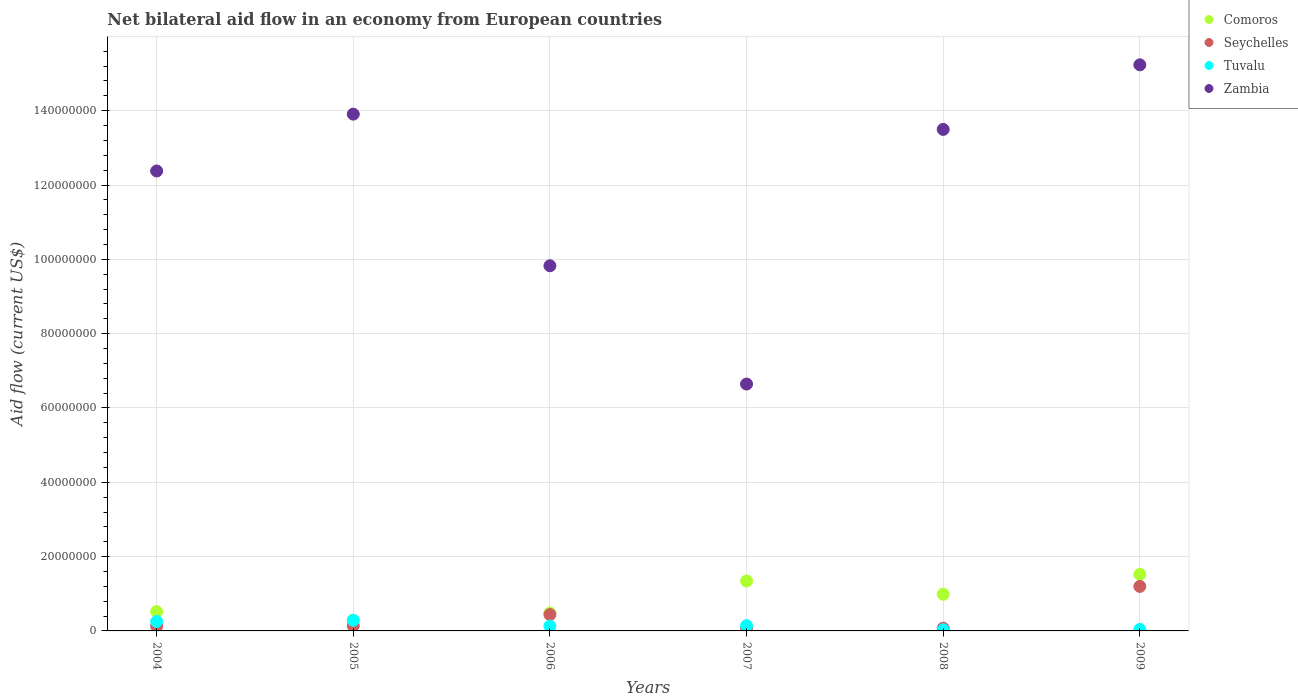What is the net bilateral aid flow in Seychelles in 2008?
Provide a succinct answer. 7.40e+05. Across all years, what is the maximum net bilateral aid flow in Seychelles?
Ensure brevity in your answer.  1.20e+07. Across all years, what is the minimum net bilateral aid flow in Comoros?
Your answer should be compact. 2.88e+06. In which year was the net bilateral aid flow in Comoros minimum?
Your answer should be compact. 2005. What is the total net bilateral aid flow in Comoros in the graph?
Your response must be concise. 5.14e+07. What is the difference between the net bilateral aid flow in Zambia in 2007 and that in 2008?
Give a very brief answer. -6.85e+07. What is the difference between the net bilateral aid flow in Comoros in 2008 and the net bilateral aid flow in Zambia in 2007?
Provide a succinct answer. -5.66e+07. What is the average net bilateral aid flow in Tuvalu per year?
Provide a succinct answer. 1.47e+06. In the year 2005, what is the difference between the net bilateral aid flow in Comoros and net bilateral aid flow in Zambia?
Offer a very short reply. -1.36e+08. In how many years, is the net bilateral aid flow in Seychelles greater than 152000000 US$?
Your answer should be compact. 0. What is the ratio of the net bilateral aid flow in Tuvalu in 2004 to that in 2007?
Your answer should be compact. 1.79. What is the difference between the highest and the second highest net bilateral aid flow in Zambia?
Your answer should be very brief. 1.33e+07. What is the difference between the highest and the lowest net bilateral aid flow in Zambia?
Make the answer very short. 8.59e+07. In how many years, is the net bilateral aid flow in Tuvalu greater than the average net bilateral aid flow in Tuvalu taken over all years?
Keep it short and to the point. 2. Does the net bilateral aid flow in Seychelles monotonically increase over the years?
Your response must be concise. No. Is the net bilateral aid flow in Comoros strictly greater than the net bilateral aid flow in Tuvalu over the years?
Your answer should be compact. Yes. Is the net bilateral aid flow in Zambia strictly less than the net bilateral aid flow in Seychelles over the years?
Offer a very short reply. No. How many dotlines are there?
Your answer should be very brief. 4. What is the difference between two consecutive major ticks on the Y-axis?
Make the answer very short. 2.00e+07. Are the values on the major ticks of Y-axis written in scientific E-notation?
Give a very brief answer. No. Does the graph contain grids?
Your response must be concise. Yes. How many legend labels are there?
Offer a terse response. 4. How are the legend labels stacked?
Ensure brevity in your answer.  Vertical. What is the title of the graph?
Ensure brevity in your answer.  Net bilateral aid flow in an economy from European countries. What is the label or title of the X-axis?
Offer a terse response. Years. What is the label or title of the Y-axis?
Make the answer very short. Aid flow (current US$). What is the Aid flow (current US$) of Comoros in 2004?
Give a very brief answer. 5.19e+06. What is the Aid flow (current US$) of Seychelles in 2004?
Offer a terse response. 1.30e+06. What is the Aid flow (current US$) of Tuvalu in 2004?
Your answer should be very brief. 2.53e+06. What is the Aid flow (current US$) in Zambia in 2004?
Provide a short and direct response. 1.24e+08. What is the Aid flow (current US$) of Comoros in 2005?
Ensure brevity in your answer.  2.88e+06. What is the Aid flow (current US$) in Seychelles in 2005?
Give a very brief answer. 1.40e+06. What is the Aid flow (current US$) in Tuvalu in 2005?
Offer a very short reply. 2.86e+06. What is the Aid flow (current US$) of Zambia in 2005?
Your response must be concise. 1.39e+08. What is the Aid flow (current US$) in Comoros in 2006?
Your answer should be very brief. 4.81e+06. What is the Aid flow (current US$) in Seychelles in 2006?
Give a very brief answer. 4.40e+06. What is the Aid flow (current US$) in Tuvalu in 2006?
Offer a terse response. 1.31e+06. What is the Aid flow (current US$) of Zambia in 2006?
Make the answer very short. 9.83e+07. What is the Aid flow (current US$) of Comoros in 2007?
Your response must be concise. 1.34e+07. What is the Aid flow (current US$) of Tuvalu in 2007?
Ensure brevity in your answer.  1.41e+06. What is the Aid flow (current US$) in Zambia in 2007?
Your response must be concise. 6.64e+07. What is the Aid flow (current US$) in Comoros in 2008?
Your response must be concise. 9.87e+06. What is the Aid flow (current US$) of Seychelles in 2008?
Offer a very short reply. 7.40e+05. What is the Aid flow (current US$) of Zambia in 2008?
Your answer should be very brief. 1.35e+08. What is the Aid flow (current US$) in Comoros in 2009?
Offer a very short reply. 1.52e+07. What is the Aid flow (current US$) in Seychelles in 2009?
Make the answer very short. 1.20e+07. What is the Aid flow (current US$) in Tuvalu in 2009?
Provide a succinct answer. 4.10e+05. What is the Aid flow (current US$) in Zambia in 2009?
Offer a very short reply. 1.52e+08. Across all years, what is the maximum Aid flow (current US$) in Comoros?
Offer a terse response. 1.52e+07. Across all years, what is the maximum Aid flow (current US$) of Seychelles?
Give a very brief answer. 1.20e+07. Across all years, what is the maximum Aid flow (current US$) in Tuvalu?
Ensure brevity in your answer.  2.86e+06. Across all years, what is the maximum Aid flow (current US$) in Zambia?
Your answer should be very brief. 1.52e+08. Across all years, what is the minimum Aid flow (current US$) of Comoros?
Your answer should be compact. 2.88e+06. Across all years, what is the minimum Aid flow (current US$) of Seychelles?
Provide a short and direct response. 7.40e+05. Across all years, what is the minimum Aid flow (current US$) in Tuvalu?
Give a very brief answer. 3.20e+05. Across all years, what is the minimum Aid flow (current US$) in Zambia?
Offer a terse response. 6.64e+07. What is the total Aid flow (current US$) in Comoros in the graph?
Your response must be concise. 5.14e+07. What is the total Aid flow (current US$) of Seychelles in the graph?
Offer a terse response. 2.06e+07. What is the total Aid flow (current US$) in Tuvalu in the graph?
Offer a terse response. 8.84e+06. What is the total Aid flow (current US$) of Zambia in the graph?
Offer a very short reply. 7.15e+08. What is the difference between the Aid flow (current US$) of Comoros in 2004 and that in 2005?
Give a very brief answer. 2.31e+06. What is the difference between the Aid flow (current US$) in Tuvalu in 2004 and that in 2005?
Make the answer very short. -3.30e+05. What is the difference between the Aid flow (current US$) in Zambia in 2004 and that in 2005?
Provide a short and direct response. -1.53e+07. What is the difference between the Aid flow (current US$) of Seychelles in 2004 and that in 2006?
Offer a very short reply. -3.10e+06. What is the difference between the Aid flow (current US$) of Tuvalu in 2004 and that in 2006?
Ensure brevity in your answer.  1.22e+06. What is the difference between the Aid flow (current US$) in Zambia in 2004 and that in 2006?
Your answer should be compact. 2.55e+07. What is the difference between the Aid flow (current US$) of Comoros in 2004 and that in 2007?
Ensure brevity in your answer.  -8.25e+06. What is the difference between the Aid flow (current US$) of Tuvalu in 2004 and that in 2007?
Give a very brief answer. 1.12e+06. What is the difference between the Aid flow (current US$) in Zambia in 2004 and that in 2007?
Provide a succinct answer. 5.73e+07. What is the difference between the Aid flow (current US$) in Comoros in 2004 and that in 2008?
Offer a very short reply. -4.68e+06. What is the difference between the Aid flow (current US$) in Seychelles in 2004 and that in 2008?
Your answer should be compact. 5.60e+05. What is the difference between the Aid flow (current US$) in Tuvalu in 2004 and that in 2008?
Your answer should be very brief. 2.21e+06. What is the difference between the Aid flow (current US$) of Zambia in 2004 and that in 2008?
Provide a succinct answer. -1.12e+07. What is the difference between the Aid flow (current US$) of Comoros in 2004 and that in 2009?
Ensure brevity in your answer.  -1.00e+07. What is the difference between the Aid flow (current US$) of Seychelles in 2004 and that in 2009?
Ensure brevity in your answer.  -1.07e+07. What is the difference between the Aid flow (current US$) of Tuvalu in 2004 and that in 2009?
Provide a short and direct response. 2.12e+06. What is the difference between the Aid flow (current US$) in Zambia in 2004 and that in 2009?
Make the answer very short. -2.86e+07. What is the difference between the Aid flow (current US$) in Comoros in 2005 and that in 2006?
Your answer should be compact. -1.93e+06. What is the difference between the Aid flow (current US$) of Tuvalu in 2005 and that in 2006?
Offer a terse response. 1.55e+06. What is the difference between the Aid flow (current US$) in Zambia in 2005 and that in 2006?
Keep it short and to the point. 4.08e+07. What is the difference between the Aid flow (current US$) in Comoros in 2005 and that in 2007?
Provide a short and direct response. -1.06e+07. What is the difference between the Aid flow (current US$) of Tuvalu in 2005 and that in 2007?
Your answer should be very brief. 1.45e+06. What is the difference between the Aid flow (current US$) in Zambia in 2005 and that in 2007?
Give a very brief answer. 7.26e+07. What is the difference between the Aid flow (current US$) in Comoros in 2005 and that in 2008?
Provide a short and direct response. -6.99e+06. What is the difference between the Aid flow (current US$) of Tuvalu in 2005 and that in 2008?
Your answer should be very brief. 2.54e+06. What is the difference between the Aid flow (current US$) in Zambia in 2005 and that in 2008?
Offer a terse response. 4.11e+06. What is the difference between the Aid flow (current US$) in Comoros in 2005 and that in 2009?
Give a very brief answer. -1.24e+07. What is the difference between the Aid flow (current US$) of Seychelles in 2005 and that in 2009?
Offer a terse response. -1.06e+07. What is the difference between the Aid flow (current US$) in Tuvalu in 2005 and that in 2009?
Give a very brief answer. 2.45e+06. What is the difference between the Aid flow (current US$) of Zambia in 2005 and that in 2009?
Your response must be concise. -1.33e+07. What is the difference between the Aid flow (current US$) in Comoros in 2006 and that in 2007?
Give a very brief answer. -8.63e+06. What is the difference between the Aid flow (current US$) in Seychelles in 2006 and that in 2007?
Provide a short and direct response. 3.60e+06. What is the difference between the Aid flow (current US$) of Zambia in 2006 and that in 2007?
Keep it short and to the point. 3.18e+07. What is the difference between the Aid flow (current US$) of Comoros in 2006 and that in 2008?
Ensure brevity in your answer.  -5.06e+06. What is the difference between the Aid flow (current US$) in Seychelles in 2006 and that in 2008?
Provide a short and direct response. 3.66e+06. What is the difference between the Aid flow (current US$) in Tuvalu in 2006 and that in 2008?
Keep it short and to the point. 9.90e+05. What is the difference between the Aid flow (current US$) in Zambia in 2006 and that in 2008?
Provide a succinct answer. -3.67e+07. What is the difference between the Aid flow (current US$) in Comoros in 2006 and that in 2009?
Give a very brief answer. -1.04e+07. What is the difference between the Aid flow (current US$) of Seychelles in 2006 and that in 2009?
Keep it short and to the point. -7.58e+06. What is the difference between the Aid flow (current US$) in Tuvalu in 2006 and that in 2009?
Offer a terse response. 9.00e+05. What is the difference between the Aid flow (current US$) of Zambia in 2006 and that in 2009?
Your answer should be very brief. -5.41e+07. What is the difference between the Aid flow (current US$) in Comoros in 2007 and that in 2008?
Provide a succinct answer. 3.57e+06. What is the difference between the Aid flow (current US$) in Tuvalu in 2007 and that in 2008?
Offer a very short reply. 1.09e+06. What is the difference between the Aid flow (current US$) of Zambia in 2007 and that in 2008?
Your response must be concise. -6.85e+07. What is the difference between the Aid flow (current US$) of Comoros in 2007 and that in 2009?
Your answer should be very brief. -1.79e+06. What is the difference between the Aid flow (current US$) in Seychelles in 2007 and that in 2009?
Ensure brevity in your answer.  -1.12e+07. What is the difference between the Aid flow (current US$) of Zambia in 2007 and that in 2009?
Your response must be concise. -8.59e+07. What is the difference between the Aid flow (current US$) of Comoros in 2008 and that in 2009?
Provide a succinct answer. -5.36e+06. What is the difference between the Aid flow (current US$) in Seychelles in 2008 and that in 2009?
Keep it short and to the point. -1.12e+07. What is the difference between the Aid flow (current US$) in Zambia in 2008 and that in 2009?
Your answer should be compact. -1.74e+07. What is the difference between the Aid flow (current US$) of Comoros in 2004 and the Aid flow (current US$) of Seychelles in 2005?
Ensure brevity in your answer.  3.79e+06. What is the difference between the Aid flow (current US$) in Comoros in 2004 and the Aid flow (current US$) in Tuvalu in 2005?
Offer a terse response. 2.33e+06. What is the difference between the Aid flow (current US$) in Comoros in 2004 and the Aid flow (current US$) in Zambia in 2005?
Your answer should be very brief. -1.34e+08. What is the difference between the Aid flow (current US$) of Seychelles in 2004 and the Aid flow (current US$) of Tuvalu in 2005?
Your answer should be very brief. -1.56e+06. What is the difference between the Aid flow (current US$) in Seychelles in 2004 and the Aid flow (current US$) in Zambia in 2005?
Offer a terse response. -1.38e+08. What is the difference between the Aid flow (current US$) of Tuvalu in 2004 and the Aid flow (current US$) of Zambia in 2005?
Provide a short and direct response. -1.37e+08. What is the difference between the Aid flow (current US$) in Comoros in 2004 and the Aid flow (current US$) in Seychelles in 2006?
Your answer should be very brief. 7.90e+05. What is the difference between the Aid flow (current US$) of Comoros in 2004 and the Aid flow (current US$) of Tuvalu in 2006?
Offer a very short reply. 3.88e+06. What is the difference between the Aid flow (current US$) in Comoros in 2004 and the Aid flow (current US$) in Zambia in 2006?
Give a very brief answer. -9.31e+07. What is the difference between the Aid flow (current US$) in Seychelles in 2004 and the Aid flow (current US$) in Tuvalu in 2006?
Keep it short and to the point. -10000. What is the difference between the Aid flow (current US$) of Seychelles in 2004 and the Aid flow (current US$) of Zambia in 2006?
Your answer should be very brief. -9.70e+07. What is the difference between the Aid flow (current US$) of Tuvalu in 2004 and the Aid flow (current US$) of Zambia in 2006?
Offer a terse response. -9.57e+07. What is the difference between the Aid flow (current US$) of Comoros in 2004 and the Aid flow (current US$) of Seychelles in 2007?
Your response must be concise. 4.39e+06. What is the difference between the Aid flow (current US$) in Comoros in 2004 and the Aid flow (current US$) in Tuvalu in 2007?
Offer a terse response. 3.78e+06. What is the difference between the Aid flow (current US$) in Comoros in 2004 and the Aid flow (current US$) in Zambia in 2007?
Offer a very short reply. -6.12e+07. What is the difference between the Aid flow (current US$) in Seychelles in 2004 and the Aid flow (current US$) in Zambia in 2007?
Your response must be concise. -6.51e+07. What is the difference between the Aid flow (current US$) of Tuvalu in 2004 and the Aid flow (current US$) of Zambia in 2007?
Offer a very short reply. -6.39e+07. What is the difference between the Aid flow (current US$) of Comoros in 2004 and the Aid flow (current US$) of Seychelles in 2008?
Provide a short and direct response. 4.45e+06. What is the difference between the Aid flow (current US$) of Comoros in 2004 and the Aid flow (current US$) of Tuvalu in 2008?
Offer a terse response. 4.87e+06. What is the difference between the Aid flow (current US$) of Comoros in 2004 and the Aid flow (current US$) of Zambia in 2008?
Your answer should be very brief. -1.30e+08. What is the difference between the Aid flow (current US$) in Seychelles in 2004 and the Aid flow (current US$) in Tuvalu in 2008?
Provide a short and direct response. 9.80e+05. What is the difference between the Aid flow (current US$) of Seychelles in 2004 and the Aid flow (current US$) of Zambia in 2008?
Keep it short and to the point. -1.34e+08. What is the difference between the Aid flow (current US$) in Tuvalu in 2004 and the Aid flow (current US$) in Zambia in 2008?
Ensure brevity in your answer.  -1.32e+08. What is the difference between the Aid flow (current US$) of Comoros in 2004 and the Aid flow (current US$) of Seychelles in 2009?
Your answer should be compact. -6.79e+06. What is the difference between the Aid flow (current US$) in Comoros in 2004 and the Aid flow (current US$) in Tuvalu in 2009?
Offer a terse response. 4.78e+06. What is the difference between the Aid flow (current US$) of Comoros in 2004 and the Aid flow (current US$) of Zambia in 2009?
Give a very brief answer. -1.47e+08. What is the difference between the Aid flow (current US$) of Seychelles in 2004 and the Aid flow (current US$) of Tuvalu in 2009?
Your answer should be compact. 8.90e+05. What is the difference between the Aid flow (current US$) in Seychelles in 2004 and the Aid flow (current US$) in Zambia in 2009?
Offer a terse response. -1.51e+08. What is the difference between the Aid flow (current US$) in Tuvalu in 2004 and the Aid flow (current US$) in Zambia in 2009?
Make the answer very short. -1.50e+08. What is the difference between the Aid flow (current US$) in Comoros in 2005 and the Aid flow (current US$) in Seychelles in 2006?
Provide a succinct answer. -1.52e+06. What is the difference between the Aid flow (current US$) in Comoros in 2005 and the Aid flow (current US$) in Tuvalu in 2006?
Your response must be concise. 1.57e+06. What is the difference between the Aid flow (current US$) in Comoros in 2005 and the Aid flow (current US$) in Zambia in 2006?
Offer a terse response. -9.54e+07. What is the difference between the Aid flow (current US$) of Seychelles in 2005 and the Aid flow (current US$) of Zambia in 2006?
Your response must be concise. -9.69e+07. What is the difference between the Aid flow (current US$) in Tuvalu in 2005 and the Aid flow (current US$) in Zambia in 2006?
Ensure brevity in your answer.  -9.54e+07. What is the difference between the Aid flow (current US$) in Comoros in 2005 and the Aid flow (current US$) in Seychelles in 2007?
Provide a succinct answer. 2.08e+06. What is the difference between the Aid flow (current US$) in Comoros in 2005 and the Aid flow (current US$) in Tuvalu in 2007?
Provide a short and direct response. 1.47e+06. What is the difference between the Aid flow (current US$) in Comoros in 2005 and the Aid flow (current US$) in Zambia in 2007?
Offer a very short reply. -6.36e+07. What is the difference between the Aid flow (current US$) of Seychelles in 2005 and the Aid flow (current US$) of Zambia in 2007?
Ensure brevity in your answer.  -6.50e+07. What is the difference between the Aid flow (current US$) in Tuvalu in 2005 and the Aid flow (current US$) in Zambia in 2007?
Keep it short and to the point. -6.36e+07. What is the difference between the Aid flow (current US$) in Comoros in 2005 and the Aid flow (current US$) in Seychelles in 2008?
Your answer should be very brief. 2.14e+06. What is the difference between the Aid flow (current US$) of Comoros in 2005 and the Aid flow (current US$) of Tuvalu in 2008?
Give a very brief answer. 2.56e+06. What is the difference between the Aid flow (current US$) in Comoros in 2005 and the Aid flow (current US$) in Zambia in 2008?
Your answer should be very brief. -1.32e+08. What is the difference between the Aid flow (current US$) of Seychelles in 2005 and the Aid flow (current US$) of Tuvalu in 2008?
Your response must be concise. 1.08e+06. What is the difference between the Aid flow (current US$) of Seychelles in 2005 and the Aid flow (current US$) of Zambia in 2008?
Give a very brief answer. -1.34e+08. What is the difference between the Aid flow (current US$) in Tuvalu in 2005 and the Aid flow (current US$) in Zambia in 2008?
Give a very brief answer. -1.32e+08. What is the difference between the Aid flow (current US$) in Comoros in 2005 and the Aid flow (current US$) in Seychelles in 2009?
Your response must be concise. -9.10e+06. What is the difference between the Aid flow (current US$) of Comoros in 2005 and the Aid flow (current US$) of Tuvalu in 2009?
Your response must be concise. 2.47e+06. What is the difference between the Aid flow (current US$) of Comoros in 2005 and the Aid flow (current US$) of Zambia in 2009?
Give a very brief answer. -1.49e+08. What is the difference between the Aid flow (current US$) in Seychelles in 2005 and the Aid flow (current US$) in Tuvalu in 2009?
Offer a very short reply. 9.90e+05. What is the difference between the Aid flow (current US$) of Seychelles in 2005 and the Aid flow (current US$) of Zambia in 2009?
Your answer should be compact. -1.51e+08. What is the difference between the Aid flow (current US$) in Tuvalu in 2005 and the Aid flow (current US$) in Zambia in 2009?
Give a very brief answer. -1.49e+08. What is the difference between the Aid flow (current US$) of Comoros in 2006 and the Aid flow (current US$) of Seychelles in 2007?
Make the answer very short. 4.01e+06. What is the difference between the Aid flow (current US$) in Comoros in 2006 and the Aid flow (current US$) in Tuvalu in 2007?
Your response must be concise. 3.40e+06. What is the difference between the Aid flow (current US$) in Comoros in 2006 and the Aid flow (current US$) in Zambia in 2007?
Your response must be concise. -6.16e+07. What is the difference between the Aid flow (current US$) of Seychelles in 2006 and the Aid flow (current US$) of Tuvalu in 2007?
Your answer should be very brief. 2.99e+06. What is the difference between the Aid flow (current US$) in Seychelles in 2006 and the Aid flow (current US$) in Zambia in 2007?
Ensure brevity in your answer.  -6.20e+07. What is the difference between the Aid flow (current US$) in Tuvalu in 2006 and the Aid flow (current US$) in Zambia in 2007?
Give a very brief answer. -6.51e+07. What is the difference between the Aid flow (current US$) of Comoros in 2006 and the Aid flow (current US$) of Seychelles in 2008?
Make the answer very short. 4.07e+06. What is the difference between the Aid flow (current US$) in Comoros in 2006 and the Aid flow (current US$) in Tuvalu in 2008?
Your response must be concise. 4.49e+06. What is the difference between the Aid flow (current US$) of Comoros in 2006 and the Aid flow (current US$) of Zambia in 2008?
Offer a terse response. -1.30e+08. What is the difference between the Aid flow (current US$) of Seychelles in 2006 and the Aid flow (current US$) of Tuvalu in 2008?
Your answer should be compact. 4.08e+06. What is the difference between the Aid flow (current US$) of Seychelles in 2006 and the Aid flow (current US$) of Zambia in 2008?
Offer a very short reply. -1.31e+08. What is the difference between the Aid flow (current US$) of Tuvalu in 2006 and the Aid flow (current US$) of Zambia in 2008?
Provide a short and direct response. -1.34e+08. What is the difference between the Aid flow (current US$) of Comoros in 2006 and the Aid flow (current US$) of Seychelles in 2009?
Provide a succinct answer. -7.17e+06. What is the difference between the Aid flow (current US$) of Comoros in 2006 and the Aid flow (current US$) of Tuvalu in 2009?
Keep it short and to the point. 4.40e+06. What is the difference between the Aid flow (current US$) of Comoros in 2006 and the Aid flow (current US$) of Zambia in 2009?
Your answer should be very brief. -1.48e+08. What is the difference between the Aid flow (current US$) in Seychelles in 2006 and the Aid flow (current US$) in Tuvalu in 2009?
Provide a short and direct response. 3.99e+06. What is the difference between the Aid flow (current US$) in Seychelles in 2006 and the Aid flow (current US$) in Zambia in 2009?
Provide a succinct answer. -1.48e+08. What is the difference between the Aid flow (current US$) in Tuvalu in 2006 and the Aid flow (current US$) in Zambia in 2009?
Make the answer very short. -1.51e+08. What is the difference between the Aid flow (current US$) of Comoros in 2007 and the Aid flow (current US$) of Seychelles in 2008?
Your response must be concise. 1.27e+07. What is the difference between the Aid flow (current US$) of Comoros in 2007 and the Aid flow (current US$) of Tuvalu in 2008?
Provide a short and direct response. 1.31e+07. What is the difference between the Aid flow (current US$) in Comoros in 2007 and the Aid flow (current US$) in Zambia in 2008?
Offer a terse response. -1.22e+08. What is the difference between the Aid flow (current US$) in Seychelles in 2007 and the Aid flow (current US$) in Zambia in 2008?
Offer a terse response. -1.34e+08. What is the difference between the Aid flow (current US$) in Tuvalu in 2007 and the Aid flow (current US$) in Zambia in 2008?
Offer a very short reply. -1.34e+08. What is the difference between the Aid flow (current US$) in Comoros in 2007 and the Aid flow (current US$) in Seychelles in 2009?
Your answer should be compact. 1.46e+06. What is the difference between the Aid flow (current US$) of Comoros in 2007 and the Aid flow (current US$) of Tuvalu in 2009?
Provide a succinct answer. 1.30e+07. What is the difference between the Aid flow (current US$) of Comoros in 2007 and the Aid flow (current US$) of Zambia in 2009?
Ensure brevity in your answer.  -1.39e+08. What is the difference between the Aid flow (current US$) of Seychelles in 2007 and the Aid flow (current US$) of Tuvalu in 2009?
Provide a succinct answer. 3.90e+05. What is the difference between the Aid flow (current US$) in Seychelles in 2007 and the Aid flow (current US$) in Zambia in 2009?
Give a very brief answer. -1.52e+08. What is the difference between the Aid flow (current US$) in Tuvalu in 2007 and the Aid flow (current US$) in Zambia in 2009?
Offer a very short reply. -1.51e+08. What is the difference between the Aid flow (current US$) of Comoros in 2008 and the Aid flow (current US$) of Seychelles in 2009?
Your answer should be very brief. -2.11e+06. What is the difference between the Aid flow (current US$) of Comoros in 2008 and the Aid flow (current US$) of Tuvalu in 2009?
Your response must be concise. 9.46e+06. What is the difference between the Aid flow (current US$) in Comoros in 2008 and the Aid flow (current US$) in Zambia in 2009?
Ensure brevity in your answer.  -1.42e+08. What is the difference between the Aid flow (current US$) of Seychelles in 2008 and the Aid flow (current US$) of Tuvalu in 2009?
Ensure brevity in your answer.  3.30e+05. What is the difference between the Aid flow (current US$) in Seychelles in 2008 and the Aid flow (current US$) in Zambia in 2009?
Make the answer very short. -1.52e+08. What is the difference between the Aid flow (current US$) of Tuvalu in 2008 and the Aid flow (current US$) of Zambia in 2009?
Offer a very short reply. -1.52e+08. What is the average Aid flow (current US$) in Comoros per year?
Your answer should be very brief. 8.57e+06. What is the average Aid flow (current US$) of Seychelles per year?
Your answer should be very brief. 3.44e+06. What is the average Aid flow (current US$) of Tuvalu per year?
Your response must be concise. 1.47e+06. What is the average Aid flow (current US$) in Zambia per year?
Offer a terse response. 1.19e+08. In the year 2004, what is the difference between the Aid flow (current US$) of Comoros and Aid flow (current US$) of Seychelles?
Your response must be concise. 3.89e+06. In the year 2004, what is the difference between the Aid flow (current US$) of Comoros and Aid flow (current US$) of Tuvalu?
Offer a very short reply. 2.66e+06. In the year 2004, what is the difference between the Aid flow (current US$) in Comoros and Aid flow (current US$) in Zambia?
Your response must be concise. -1.19e+08. In the year 2004, what is the difference between the Aid flow (current US$) in Seychelles and Aid flow (current US$) in Tuvalu?
Your answer should be compact. -1.23e+06. In the year 2004, what is the difference between the Aid flow (current US$) in Seychelles and Aid flow (current US$) in Zambia?
Your answer should be very brief. -1.22e+08. In the year 2004, what is the difference between the Aid flow (current US$) of Tuvalu and Aid flow (current US$) of Zambia?
Keep it short and to the point. -1.21e+08. In the year 2005, what is the difference between the Aid flow (current US$) of Comoros and Aid flow (current US$) of Seychelles?
Provide a succinct answer. 1.48e+06. In the year 2005, what is the difference between the Aid flow (current US$) of Comoros and Aid flow (current US$) of Zambia?
Make the answer very short. -1.36e+08. In the year 2005, what is the difference between the Aid flow (current US$) in Seychelles and Aid flow (current US$) in Tuvalu?
Ensure brevity in your answer.  -1.46e+06. In the year 2005, what is the difference between the Aid flow (current US$) of Seychelles and Aid flow (current US$) of Zambia?
Give a very brief answer. -1.38e+08. In the year 2005, what is the difference between the Aid flow (current US$) of Tuvalu and Aid flow (current US$) of Zambia?
Your answer should be very brief. -1.36e+08. In the year 2006, what is the difference between the Aid flow (current US$) in Comoros and Aid flow (current US$) in Seychelles?
Give a very brief answer. 4.10e+05. In the year 2006, what is the difference between the Aid flow (current US$) in Comoros and Aid flow (current US$) in Tuvalu?
Offer a very short reply. 3.50e+06. In the year 2006, what is the difference between the Aid flow (current US$) of Comoros and Aid flow (current US$) of Zambia?
Give a very brief answer. -9.35e+07. In the year 2006, what is the difference between the Aid flow (current US$) of Seychelles and Aid flow (current US$) of Tuvalu?
Give a very brief answer. 3.09e+06. In the year 2006, what is the difference between the Aid flow (current US$) in Seychelles and Aid flow (current US$) in Zambia?
Your response must be concise. -9.39e+07. In the year 2006, what is the difference between the Aid flow (current US$) in Tuvalu and Aid flow (current US$) in Zambia?
Offer a terse response. -9.70e+07. In the year 2007, what is the difference between the Aid flow (current US$) of Comoros and Aid flow (current US$) of Seychelles?
Your response must be concise. 1.26e+07. In the year 2007, what is the difference between the Aid flow (current US$) in Comoros and Aid flow (current US$) in Tuvalu?
Provide a succinct answer. 1.20e+07. In the year 2007, what is the difference between the Aid flow (current US$) in Comoros and Aid flow (current US$) in Zambia?
Provide a succinct answer. -5.30e+07. In the year 2007, what is the difference between the Aid flow (current US$) of Seychelles and Aid flow (current US$) of Tuvalu?
Ensure brevity in your answer.  -6.10e+05. In the year 2007, what is the difference between the Aid flow (current US$) in Seychelles and Aid flow (current US$) in Zambia?
Make the answer very short. -6.56e+07. In the year 2007, what is the difference between the Aid flow (current US$) in Tuvalu and Aid flow (current US$) in Zambia?
Your response must be concise. -6.50e+07. In the year 2008, what is the difference between the Aid flow (current US$) in Comoros and Aid flow (current US$) in Seychelles?
Keep it short and to the point. 9.13e+06. In the year 2008, what is the difference between the Aid flow (current US$) in Comoros and Aid flow (current US$) in Tuvalu?
Your response must be concise. 9.55e+06. In the year 2008, what is the difference between the Aid flow (current US$) in Comoros and Aid flow (current US$) in Zambia?
Provide a short and direct response. -1.25e+08. In the year 2008, what is the difference between the Aid flow (current US$) of Seychelles and Aid flow (current US$) of Zambia?
Provide a short and direct response. -1.34e+08. In the year 2008, what is the difference between the Aid flow (current US$) of Tuvalu and Aid flow (current US$) of Zambia?
Make the answer very short. -1.35e+08. In the year 2009, what is the difference between the Aid flow (current US$) in Comoros and Aid flow (current US$) in Seychelles?
Offer a terse response. 3.25e+06. In the year 2009, what is the difference between the Aid flow (current US$) in Comoros and Aid flow (current US$) in Tuvalu?
Provide a succinct answer. 1.48e+07. In the year 2009, what is the difference between the Aid flow (current US$) in Comoros and Aid flow (current US$) in Zambia?
Keep it short and to the point. -1.37e+08. In the year 2009, what is the difference between the Aid flow (current US$) of Seychelles and Aid flow (current US$) of Tuvalu?
Offer a very short reply. 1.16e+07. In the year 2009, what is the difference between the Aid flow (current US$) of Seychelles and Aid flow (current US$) of Zambia?
Offer a terse response. -1.40e+08. In the year 2009, what is the difference between the Aid flow (current US$) of Tuvalu and Aid flow (current US$) of Zambia?
Keep it short and to the point. -1.52e+08. What is the ratio of the Aid flow (current US$) of Comoros in 2004 to that in 2005?
Keep it short and to the point. 1.8. What is the ratio of the Aid flow (current US$) in Tuvalu in 2004 to that in 2005?
Keep it short and to the point. 0.88. What is the ratio of the Aid flow (current US$) in Zambia in 2004 to that in 2005?
Provide a succinct answer. 0.89. What is the ratio of the Aid flow (current US$) of Comoros in 2004 to that in 2006?
Keep it short and to the point. 1.08. What is the ratio of the Aid flow (current US$) of Seychelles in 2004 to that in 2006?
Make the answer very short. 0.3. What is the ratio of the Aid flow (current US$) in Tuvalu in 2004 to that in 2006?
Keep it short and to the point. 1.93. What is the ratio of the Aid flow (current US$) in Zambia in 2004 to that in 2006?
Provide a short and direct response. 1.26. What is the ratio of the Aid flow (current US$) in Comoros in 2004 to that in 2007?
Ensure brevity in your answer.  0.39. What is the ratio of the Aid flow (current US$) of Seychelles in 2004 to that in 2007?
Offer a very short reply. 1.62. What is the ratio of the Aid flow (current US$) of Tuvalu in 2004 to that in 2007?
Offer a very short reply. 1.79. What is the ratio of the Aid flow (current US$) in Zambia in 2004 to that in 2007?
Ensure brevity in your answer.  1.86. What is the ratio of the Aid flow (current US$) of Comoros in 2004 to that in 2008?
Offer a very short reply. 0.53. What is the ratio of the Aid flow (current US$) in Seychelles in 2004 to that in 2008?
Offer a terse response. 1.76. What is the ratio of the Aid flow (current US$) of Tuvalu in 2004 to that in 2008?
Provide a short and direct response. 7.91. What is the ratio of the Aid flow (current US$) in Zambia in 2004 to that in 2008?
Give a very brief answer. 0.92. What is the ratio of the Aid flow (current US$) of Comoros in 2004 to that in 2009?
Keep it short and to the point. 0.34. What is the ratio of the Aid flow (current US$) in Seychelles in 2004 to that in 2009?
Your answer should be very brief. 0.11. What is the ratio of the Aid flow (current US$) in Tuvalu in 2004 to that in 2009?
Keep it short and to the point. 6.17. What is the ratio of the Aid flow (current US$) in Zambia in 2004 to that in 2009?
Your answer should be compact. 0.81. What is the ratio of the Aid flow (current US$) of Comoros in 2005 to that in 2006?
Offer a very short reply. 0.6. What is the ratio of the Aid flow (current US$) in Seychelles in 2005 to that in 2006?
Your response must be concise. 0.32. What is the ratio of the Aid flow (current US$) of Tuvalu in 2005 to that in 2006?
Provide a succinct answer. 2.18. What is the ratio of the Aid flow (current US$) in Zambia in 2005 to that in 2006?
Provide a succinct answer. 1.42. What is the ratio of the Aid flow (current US$) of Comoros in 2005 to that in 2007?
Offer a terse response. 0.21. What is the ratio of the Aid flow (current US$) of Tuvalu in 2005 to that in 2007?
Keep it short and to the point. 2.03. What is the ratio of the Aid flow (current US$) of Zambia in 2005 to that in 2007?
Offer a very short reply. 2.09. What is the ratio of the Aid flow (current US$) of Comoros in 2005 to that in 2008?
Offer a terse response. 0.29. What is the ratio of the Aid flow (current US$) in Seychelles in 2005 to that in 2008?
Offer a very short reply. 1.89. What is the ratio of the Aid flow (current US$) in Tuvalu in 2005 to that in 2008?
Your response must be concise. 8.94. What is the ratio of the Aid flow (current US$) in Zambia in 2005 to that in 2008?
Ensure brevity in your answer.  1.03. What is the ratio of the Aid flow (current US$) of Comoros in 2005 to that in 2009?
Offer a terse response. 0.19. What is the ratio of the Aid flow (current US$) of Seychelles in 2005 to that in 2009?
Provide a short and direct response. 0.12. What is the ratio of the Aid flow (current US$) of Tuvalu in 2005 to that in 2009?
Keep it short and to the point. 6.98. What is the ratio of the Aid flow (current US$) in Zambia in 2005 to that in 2009?
Your answer should be very brief. 0.91. What is the ratio of the Aid flow (current US$) in Comoros in 2006 to that in 2007?
Ensure brevity in your answer.  0.36. What is the ratio of the Aid flow (current US$) in Tuvalu in 2006 to that in 2007?
Give a very brief answer. 0.93. What is the ratio of the Aid flow (current US$) of Zambia in 2006 to that in 2007?
Give a very brief answer. 1.48. What is the ratio of the Aid flow (current US$) of Comoros in 2006 to that in 2008?
Your response must be concise. 0.49. What is the ratio of the Aid flow (current US$) of Seychelles in 2006 to that in 2008?
Offer a terse response. 5.95. What is the ratio of the Aid flow (current US$) of Tuvalu in 2006 to that in 2008?
Ensure brevity in your answer.  4.09. What is the ratio of the Aid flow (current US$) of Zambia in 2006 to that in 2008?
Offer a very short reply. 0.73. What is the ratio of the Aid flow (current US$) in Comoros in 2006 to that in 2009?
Offer a terse response. 0.32. What is the ratio of the Aid flow (current US$) of Seychelles in 2006 to that in 2009?
Give a very brief answer. 0.37. What is the ratio of the Aid flow (current US$) in Tuvalu in 2006 to that in 2009?
Provide a short and direct response. 3.2. What is the ratio of the Aid flow (current US$) in Zambia in 2006 to that in 2009?
Offer a terse response. 0.65. What is the ratio of the Aid flow (current US$) of Comoros in 2007 to that in 2008?
Provide a short and direct response. 1.36. What is the ratio of the Aid flow (current US$) in Seychelles in 2007 to that in 2008?
Offer a terse response. 1.08. What is the ratio of the Aid flow (current US$) in Tuvalu in 2007 to that in 2008?
Offer a terse response. 4.41. What is the ratio of the Aid flow (current US$) in Zambia in 2007 to that in 2008?
Provide a short and direct response. 0.49. What is the ratio of the Aid flow (current US$) of Comoros in 2007 to that in 2009?
Offer a terse response. 0.88. What is the ratio of the Aid flow (current US$) in Seychelles in 2007 to that in 2009?
Make the answer very short. 0.07. What is the ratio of the Aid flow (current US$) in Tuvalu in 2007 to that in 2009?
Make the answer very short. 3.44. What is the ratio of the Aid flow (current US$) in Zambia in 2007 to that in 2009?
Make the answer very short. 0.44. What is the ratio of the Aid flow (current US$) in Comoros in 2008 to that in 2009?
Offer a very short reply. 0.65. What is the ratio of the Aid flow (current US$) of Seychelles in 2008 to that in 2009?
Your answer should be very brief. 0.06. What is the ratio of the Aid flow (current US$) in Tuvalu in 2008 to that in 2009?
Make the answer very short. 0.78. What is the ratio of the Aid flow (current US$) of Zambia in 2008 to that in 2009?
Offer a terse response. 0.89. What is the difference between the highest and the second highest Aid flow (current US$) of Comoros?
Provide a succinct answer. 1.79e+06. What is the difference between the highest and the second highest Aid flow (current US$) of Seychelles?
Offer a very short reply. 7.58e+06. What is the difference between the highest and the second highest Aid flow (current US$) of Zambia?
Your answer should be very brief. 1.33e+07. What is the difference between the highest and the lowest Aid flow (current US$) in Comoros?
Provide a succinct answer. 1.24e+07. What is the difference between the highest and the lowest Aid flow (current US$) of Seychelles?
Your answer should be very brief. 1.12e+07. What is the difference between the highest and the lowest Aid flow (current US$) in Tuvalu?
Offer a very short reply. 2.54e+06. What is the difference between the highest and the lowest Aid flow (current US$) of Zambia?
Provide a succinct answer. 8.59e+07. 